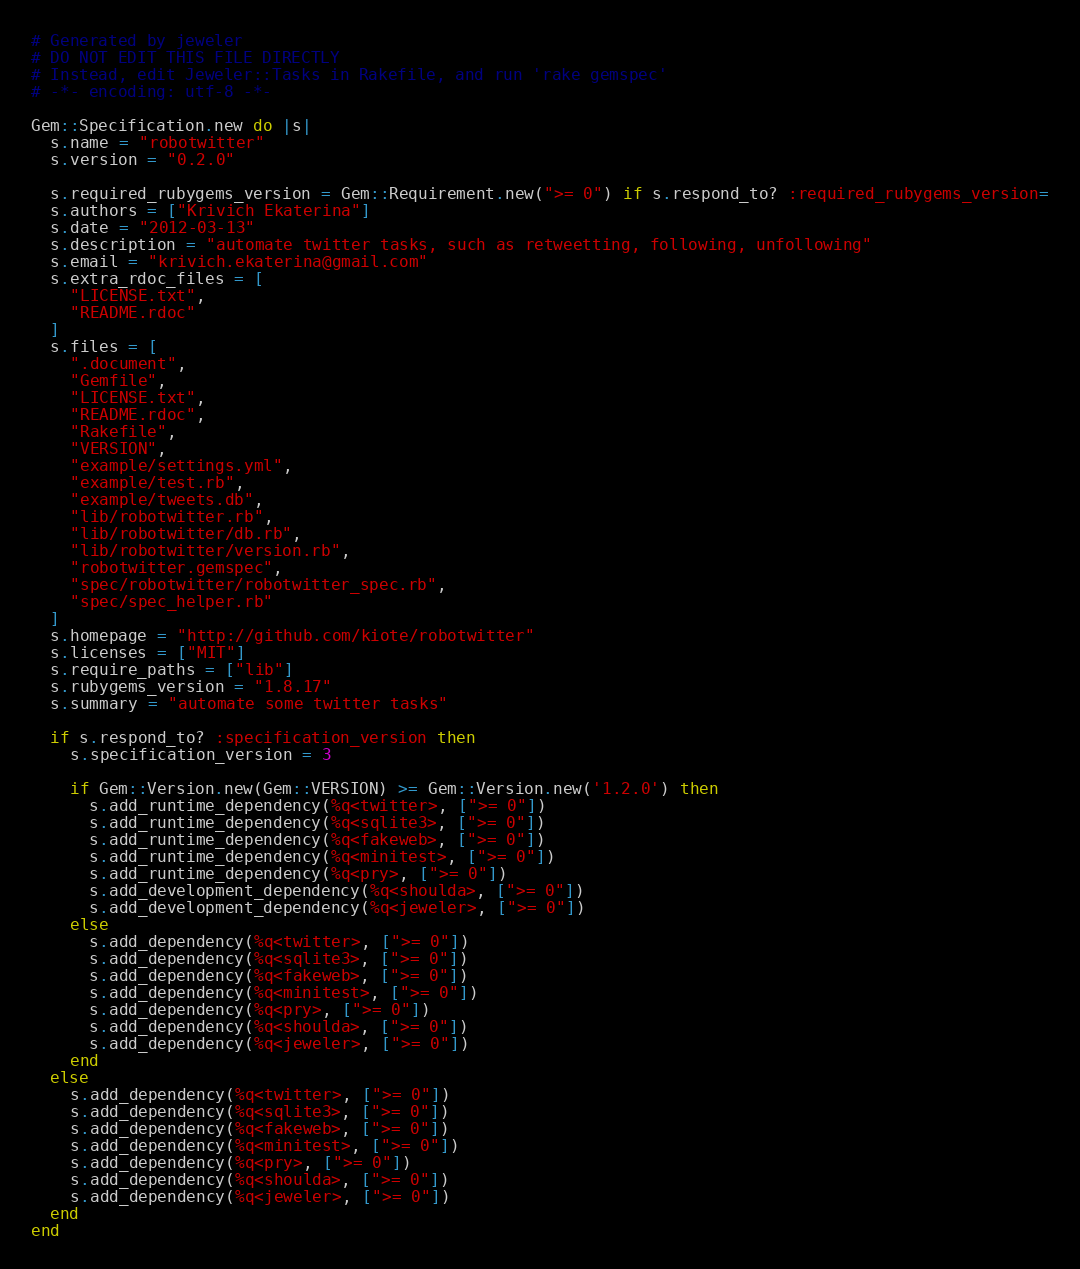<code> <loc_0><loc_0><loc_500><loc_500><_Ruby_># Generated by jeweler
# DO NOT EDIT THIS FILE DIRECTLY
# Instead, edit Jeweler::Tasks in Rakefile, and run 'rake gemspec'
# -*- encoding: utf-8 -*-

Gem::Specification.new do |s|
  s.name = "robotwitter"
  s.version = "0.2.0"

  s.required_rubygems_version = Gem::Requirement.new(">= 0") if s.respond_to? :required_rubygems_version=
  s.authors = ["Krivich Ekaterina"]
  s.date = "2012-03-13"
  s.description = "automate twitter tasks, such as retweetting, following, unfollowing"
  s.email = "krivich.ekaterina@gmail.com"
  s.extra_rdoc_files = [
    "LICENSE.txt",
    "README.rdoc"
  ]
  s.files = [
    ".document",
    "Gemfile",
    "LICENSE.txt",
    "README.rdoc",
    "Rakefile",
    "VERSION",
    "example/settings.yml",
    "example/test.rb",
    "example/tweets.db",
    "lib/robotwitter.rb",
    "lib/robotwitter/db.rb",
    "lib/robotwitter/version.rb",
    "robotwitter.gemspec",
    "spec/robotwitter/robotwitter_spec.rb",
    "spec/spec_helper.rb"
  ]
  s.homepage = "http://github.com/kiote/robotwitter"
  s.licenses = ["MIT"]
  s.require_paths = ["lib"]
  s.rubygems_version = "1.8.17"
  s.summary = "automate some twitter tasks"

  if s.respond_to? :specification_version then
    s.specification_version = 3

    if Gem::Version.new(Gem::VERSION) >= Gem::Version.new('1.2.0') then
      s.add_runtime_dependency(%q<twitter>, [">= 0"])
      s.add_runtime_dependency(%q<sqlite3>, [">= 0"])
      s.add_runtime_dependency(%q<fakeweb>, [">= 0"])
      s.add_runtime_dependency(%q<minitest>, [">= 0"])
      s.add_runtime_dependency(%q<pry>, [">= 0"])
      s.add_development_dependency(%q<shoulda>, [">= 0"])
      s.add_development_dependency(%q<jeweler>, [">= 0"])
    else
      s.add_dependency(%q<twitter>, [">= 0"])
      s.add_dependency(%q<sqlite3>, [">= 0"])
      s.add_dependency(%q<fakeweb>, [">= 0"])
      s.add_dependency(%q<minitest>, [">= 0"])
      s.add_dependency(%q<pry>, [">= 0"])
      s.add_dependency(%q<shoulda>, [">= 0"])
      s.add_dependency(%q<jeweler>, [">= 0"])
    end
  else
    s.add_dependency(%q<twitter>, [">= 0"])
    s.add_dependency(%q<sqlite3>, [">= 0"])
    s.add_dependency(%q<fakeweb>, [">= 0"])
    s.add_dependency(%q<minitest>, [">= 0"])
    s.add_dependency(%q<pry>, [">= 0"])
    s.add_dependency(%q<shoulda>, [">= 0"])
    s.add_dependency(%q<jeweler>, [">= 0"])
  end
end
</code> 